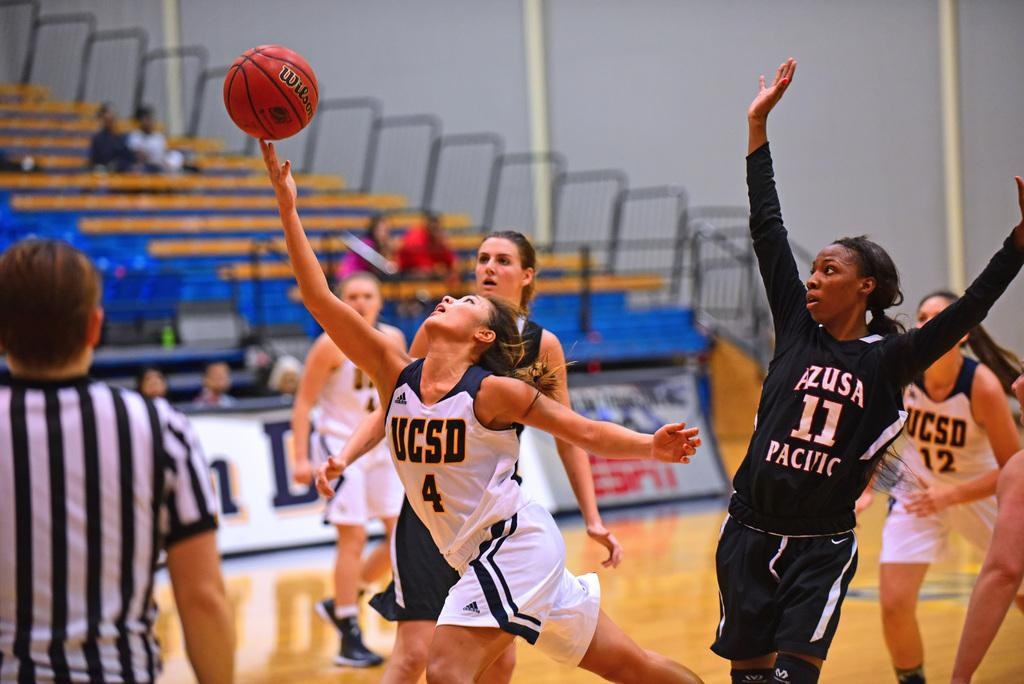Provide a one-sentence caption for the provided image. Women's college basket ball game between UCSD and AZUSA PACIFIC, players reach for the ball as a referee watches. 